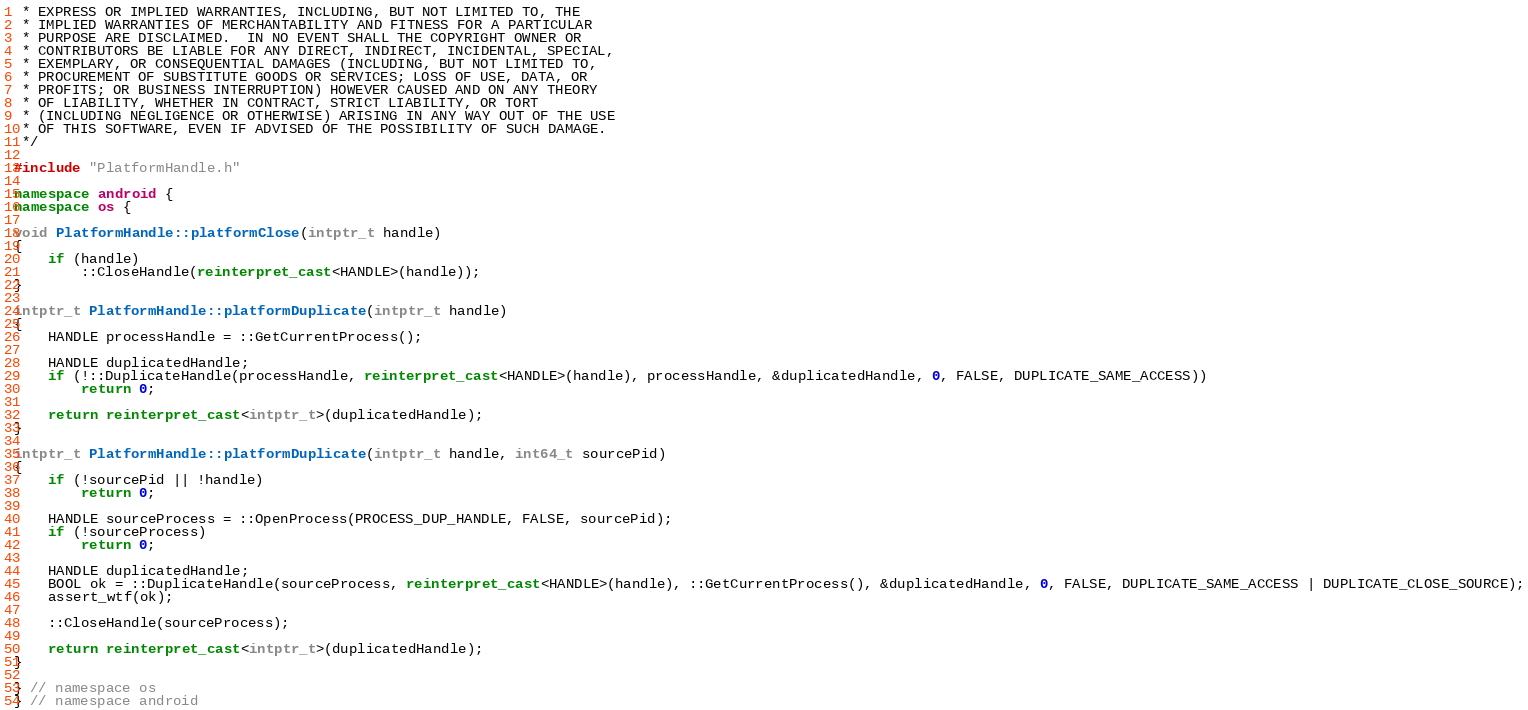<code> <loc_0><loc_0><loc_500><loc_500><_C++_> * EXPRESS OR IMPLIED WARRANTIES, INCLUDING, BUT NOT LIMITED TO, THE
 * IMPLIED WARRANTIES OF MERCHANTABILITY AND FITNESS FOR A PARTICULAR
 * PURPOSE ARE DISCLAIMED.  IN NO EVENT SHALL THE COPYRIGHT OWNER OR
 * CONTRIBUTORS BE LIABLE FOR ANY DIRECT, INDIRECT, INCIDENTAL, SPECIAL,
 * EXEMPLARY, OR CONSEQUENTIAL DAMAGES (INCLUDING, BUT NOT LIMITED TO,
 * PROCUREMENT OF SUBSTITUTE GOODS OR SERVICES; LOSS OF USE, DATA, OR
 * PROFITS; OR BUSINESS INTERRUPTION) HOWEVER CAUSED AND ON ANY THEORY
 * OF LIABILITY, WHETHER IN CONTRACT, STRICT LIABILITY, OR TORT
 * (INCLUDING NEGLIGENCE OR OTHERWISE) ARISING IN ANY WAY OUT OF THE USE
 * OF THIS SOFTWARE, EVEN IF ADVISED OF THE POSSIBILITY OF SUCH DAMAGE.
 */

#include "PlatformHandle.h"

namespace android {
namespace os {

void PlatformHandle::platformClose(intptr_t handle)
{
    if (handle)
        ::CloseHandle(reinterpret_cast<HANDLE>(handle));
}

intptr_t PlatformHandle::platformDuplicate(intptr_t handle)
{
    HANDLE processHandle = ::GetCurrentProcess();

    HANDLE duplicatedHandle;
    if (!::DuplicateHandle(processHandle, reinterpret_cast<HANDLE>(handle), processHandle, &duplicatedHandle, 0, FALSE, DUPLICATE_SAME_ACCESS))
        return 0;

    return reinterpret_cast<intptr_t>(duplicatedHandle);
}

intptr_t PlatformHandle::platformDuplicate(intptr_t handle, int64_t sourcePid)
{
    if (!sourcePid || !handle)
        return 0;

    HANDLE sourceProcess = ::OpenProcess(PROCESS_DUP_HANDLE, FALSE, sourcePid);
    if (!sourceProcess)
        return 0;

    HANDLE duplicatedHandle;
    BOOL ok = ::DuplicateHandle(sourceProcess, reinterpret_cast<HANDLE>(handle), ::GetCurrentProcess(), &duplicatedHandle, 0, FALSE, DUPLICATE_SAME_ACCESS | DUPLICATE_CLOSE_SOURCE);
    assert_wtf(ok);

    ::CloseHandle(sourceProcess);

    return reinterpret_cast<intptr_t>(duplicatedHandle);
}

} // namespace os
} // namespace android
</code> 